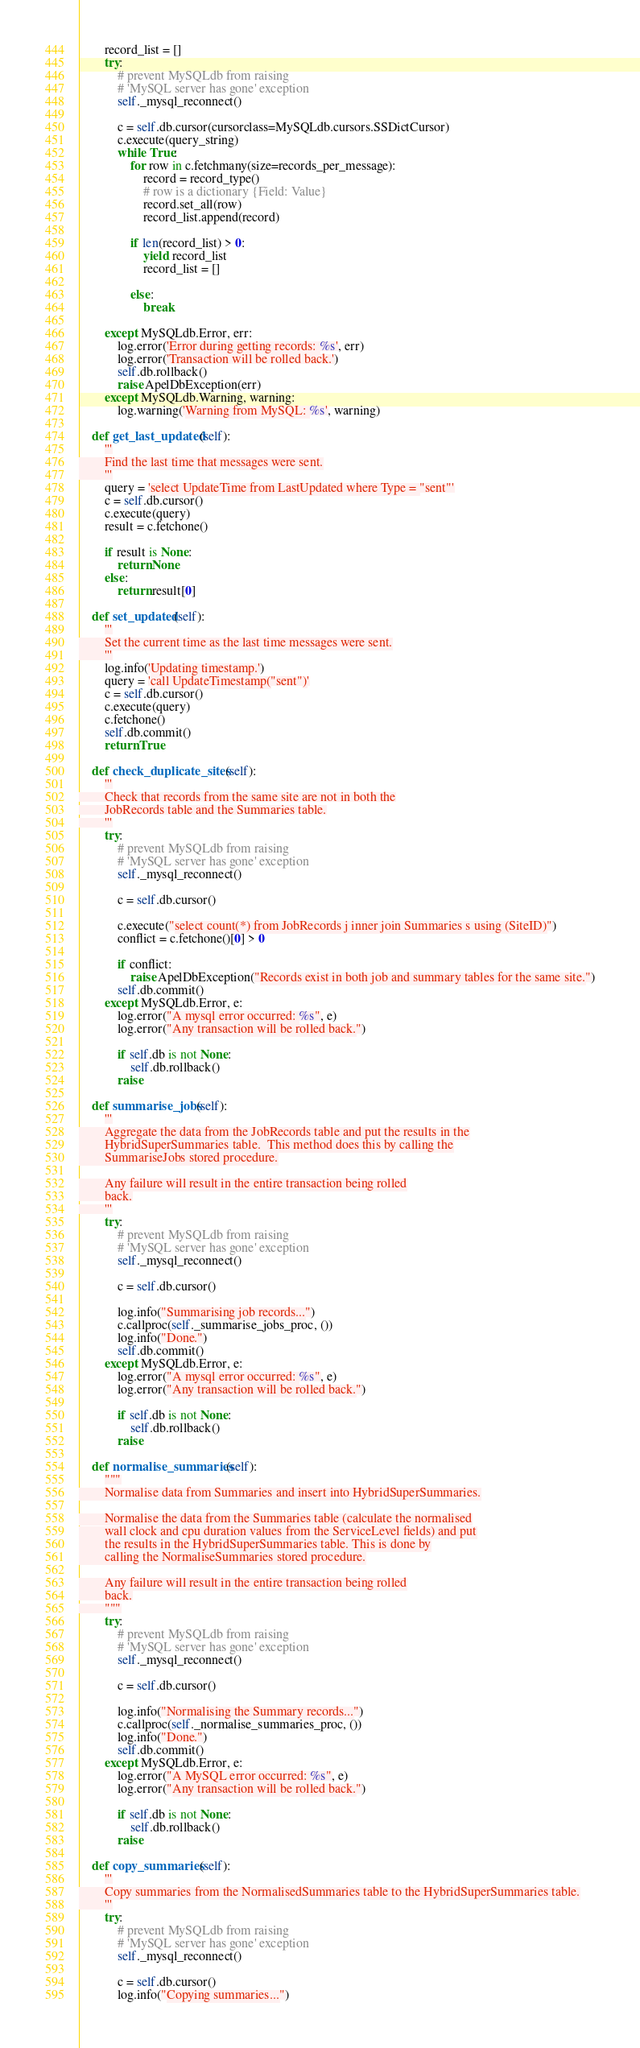<code> <loc_0><loc_0><loc_500><loc_500><_Python_>
        record_list = []
        try:
            # prevent MySQLdb from raising
            # 'MySQL server has gone' exception
            self._mysql_reconnect()

            c = self.db.cursor(cursorclass=MySQLdb.cursors.SSDictCursor)
            c.execute(query_string)
            while True:
                for row in c.fetchmany(size=records_per_message):
                    record = record_type()
                    # row is a dictionary {Field: Value}
                    record.set_all(row)
                    record_list.append(record)

                if len(record_list) > 0:
                    yield record_list
                    record_list = []

                else:
                    break

        except MySQLdb.Error, err:
            log.error('Error during getting records: %s', err)
            log.error('Transaction will be rolled back.')
            self.db.rollback()
            raise ApelDbException(err)
        except MySQLdb.Warning, warning:
            log.warning('Warning from MySQL: %s', warning)

    def get_last_updated(self):
        '''
        Find the last time that messages were sent.
        '''
        query = 'select UpdateTime from LastUpdated where Type = "sent"'
        c = self.db.cursor()
        c.execute(query)
        result = c.fetchone()

        if result is None:
            return None
        else:
            return result[0]

    def set_updated(self):
        '''
        Set the current time as the last time messages were sent.
        '''
        log.info('Updating timestamp.')
        query = 'call UpdateTimestamp("sent")'
        c = self.db.cursor()
        c.execute(query)
        c.fetchone()
        self.db.commit()
        return True

    def check_duplicate_sites(self):
        '''
        Check that records from the same site are not in both the
        JobRecords table and the Summaries table.
        '''
        try:
            # prevent MySQLdb from raising
            # 'MySQL server has gone' exception
            self._mysql_reconnect()

            c = self.db.cursor()

            c.execute("select count(*) from JobRecords j inner join Summaries s using (SiteID)")
            conflict = c.fetchone()[0] > 0

            if conflict:
                raise ApelDbException("Records exist in both job and summary tables for the same site.")
            self.db.commit()
        except MySQLdb.Error, e:
            log.error("A mysql error occurred: %s", e)
            log.error("Any transaction will be rolled back.")

            if self.db is not None:
                self.db.rollback()
            raise

    def summarise_jobs(self):
        '''
        Aggregate the data from the JobRecords table and put the results in the
        HybridSuperSummaries table.  This method does this by calling the
        SummariseJobs stored procedure.

        Any failure will result in the entire transaction being rolled
        back.
        '''
        try:
            # prevent MySQLdb from raising
            # 'MySQL server has gone' exception
            self._mysql_reconnect()

            c = self.db.cursor()

            log.info("Summarising job records...")
            c.callproc(self._summarise_jobs_proc, ())
            log.info("Done.")
            self.db.commit()
        except MySQLdb.Error, e:
            log.error("A mysql error occurred: %s", e)
            log.error("Any transaction will be rolled back.")

            if self.db is not None:
                self.db.rollback()
            raise

    def normalise_summaries(self):
        """
        Normalise data from Summaries and insert into HybridSuperSummaries.

        Normalise the data from the Summaries table (calculate the normalised
        wall clock and cpu duration values from the ServiceLevel fields) and put
        the results in the HybridSuperSummaries table. This is done by
        calling the NormaliseSummaries stored procedure.

        Any failure will result in the entire transaction being rolled
        back.
        """
        try:
            # prevent MySQLdb from raising
            # 'MySQL server has gone' exception
            self._mysql_reconnect()

            c = self.db.cursor()

            log.info("Normalising the Summary records...")
            c.callproc(self._normalise_summaries_proc, ())
            log.info("Done.")
            self.db.commit()
        except MySQLdb.Error, e:
            log.error("A MySQL error occurred: %s", e)
            log.error("Any transaction will be rolled back.")

            if self.db is not None:
                self.db.rollback()
            raise

    def copy_summaries(self):
        '''
        Copy summaries from the NormalisedSummaries table to the HybridSuperSummaries table.
        '''
        try:
            # prevent MySQLdb from raising
            # 'MySQL server has gone' exception
            self._mysql_reconnect()

            c = self.db.cursor()
            log.info("Copying summaries...")</code> 